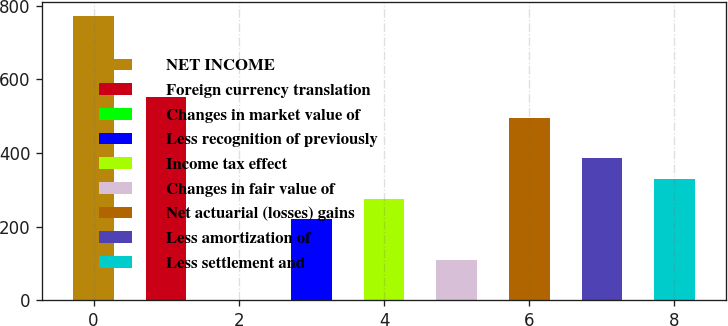<chart> <loc_0><loc_0><loc_500><loc_500><bar_chart><fcel>NET INCOME<fcel>Foreign currency translation<fcel>Changes in market value of<fcel>Less recognition of previously<fcel>Income tax effect<fcel>Changes in fair value of<fcel>Net actuarial (losses) gains<fcel>Less amortization of<fcel>Less settlement and<nl><fcel>772.06<fcel>551.5<fcel>0.1<fcel>220.66<fcel>275.8<fcel>110.38<fcel>496.36<fcel>386.08<fcel>330.94<nl></chart> 